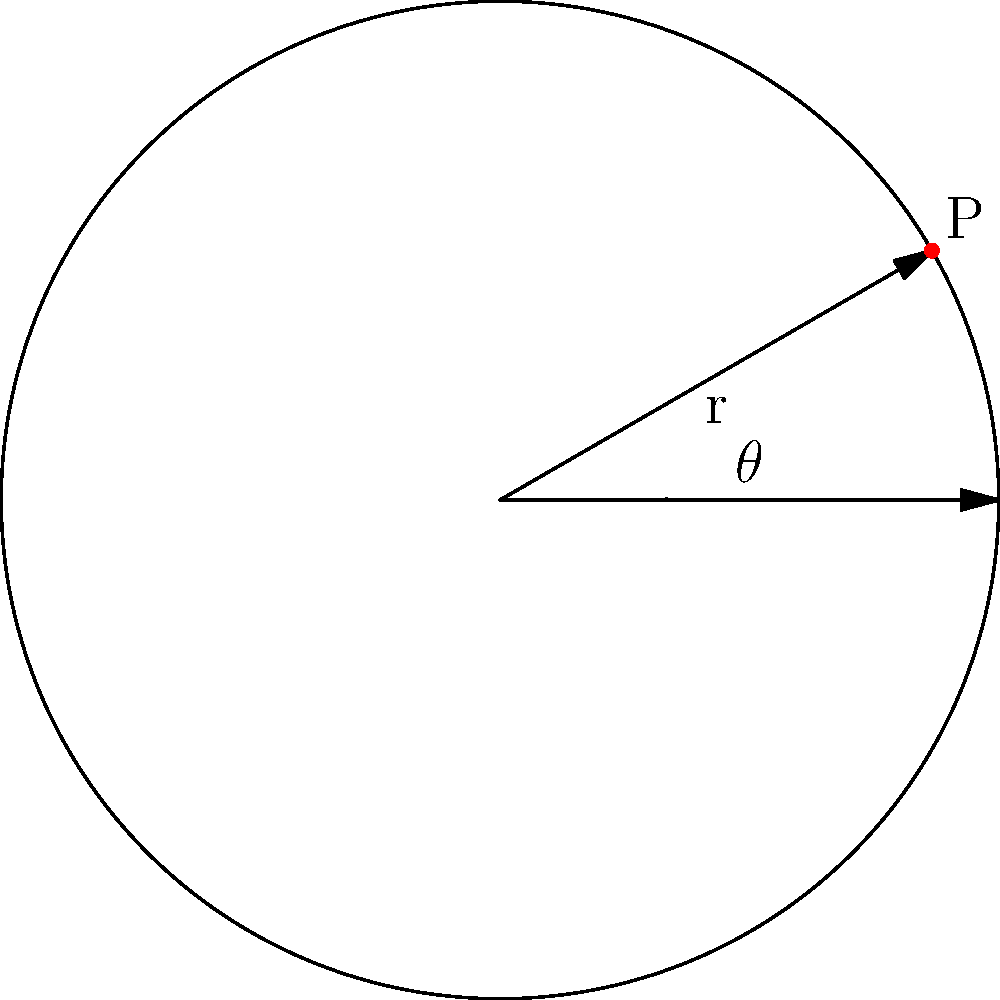In a volleyball match, you're analyzing player positions using polar coordinates. A libero is positioned at point P on the court. If the radius of the circular representation is 9 meters (court width) and the angle θ is 30°, what are the Cartesian coordinates (x, y) of the libero's position? Round your answer to two decimal places. To solve this problem, we need to convert from polar coordinates to Cartesian coordinates. Let's follow these steps:

1. Recall the conversion formulas:
   $x = r \cos(\theta)$
   $y = r \sin(\theta)$

2. We're given:
   $r = 9$ meters (radius/court width)
   $\theta = 30° = \frac{\pi}{6}$ radians (we need to convert to radians for calculations)

3. Calculate x-coordinate:
   $x = r \cos(\theta) = 9 \cos(\frac{\pi}{6}) = 9 \cdot \frac{\sqrt{3}}{2} \approx 7.79$ meters

4. Calculate y-coordinate:
   $y = r \sin(\theta) = 9 \sin(\frac{\pi}{6}) = 9 \cdot \frac{1}{2} = 4.5$ meters

5. Round both values to two decimal places:
   $x \approx 7.79$ meters
   $y \approx 4.50$ meters

Therefore, the libero's position in Cartesian coordinates is approximately (7.79, 4.50) meters.
Answer: (7.79, 4.50) 